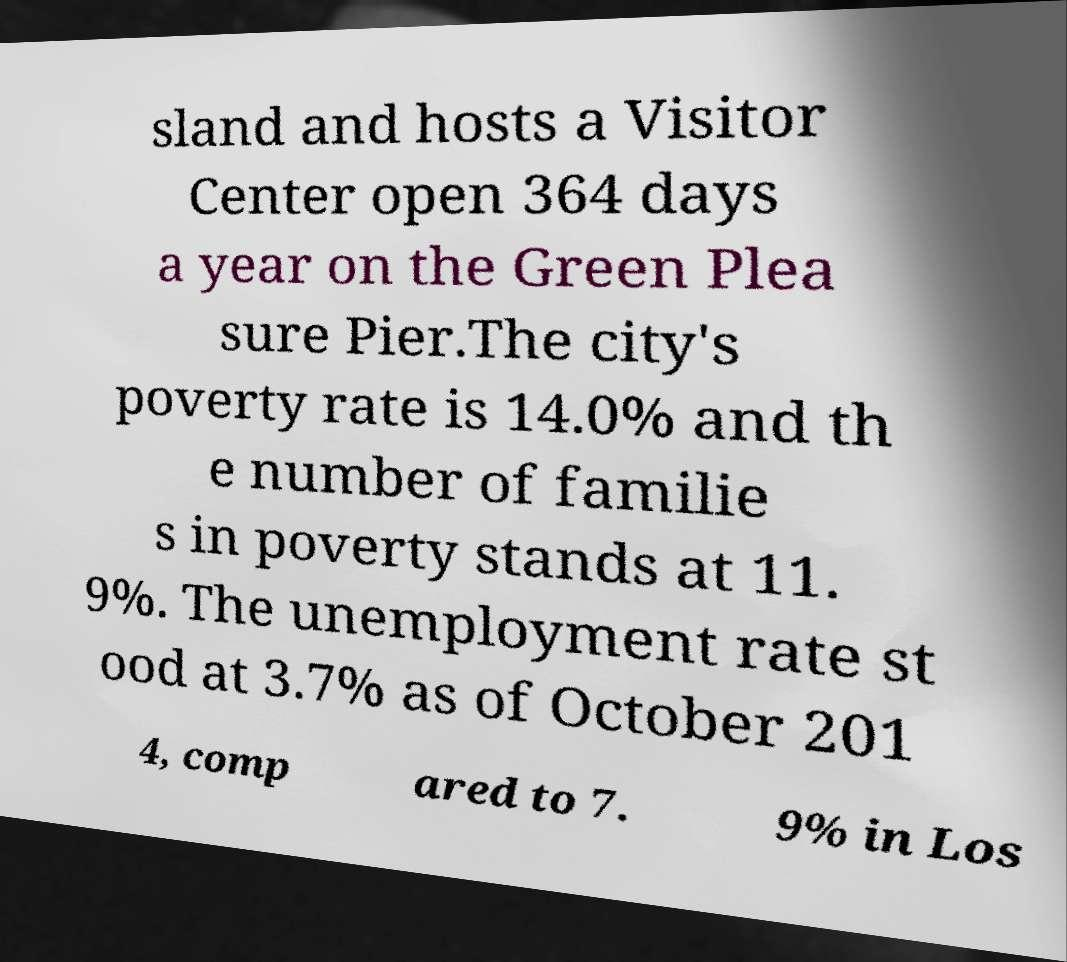What messages or text are displayed in this image? I need them in a readable, typed format. sland and hosts a Visitor Center open 364 days a year on the Green Plea sure Pier.The city's poverty rate is 14.0% and th e number of familie s in poverty stands at 11. 9%. The unemployment rate st ood at 3.7% as of October 201 4, comp ared to 7. 9% in Los 